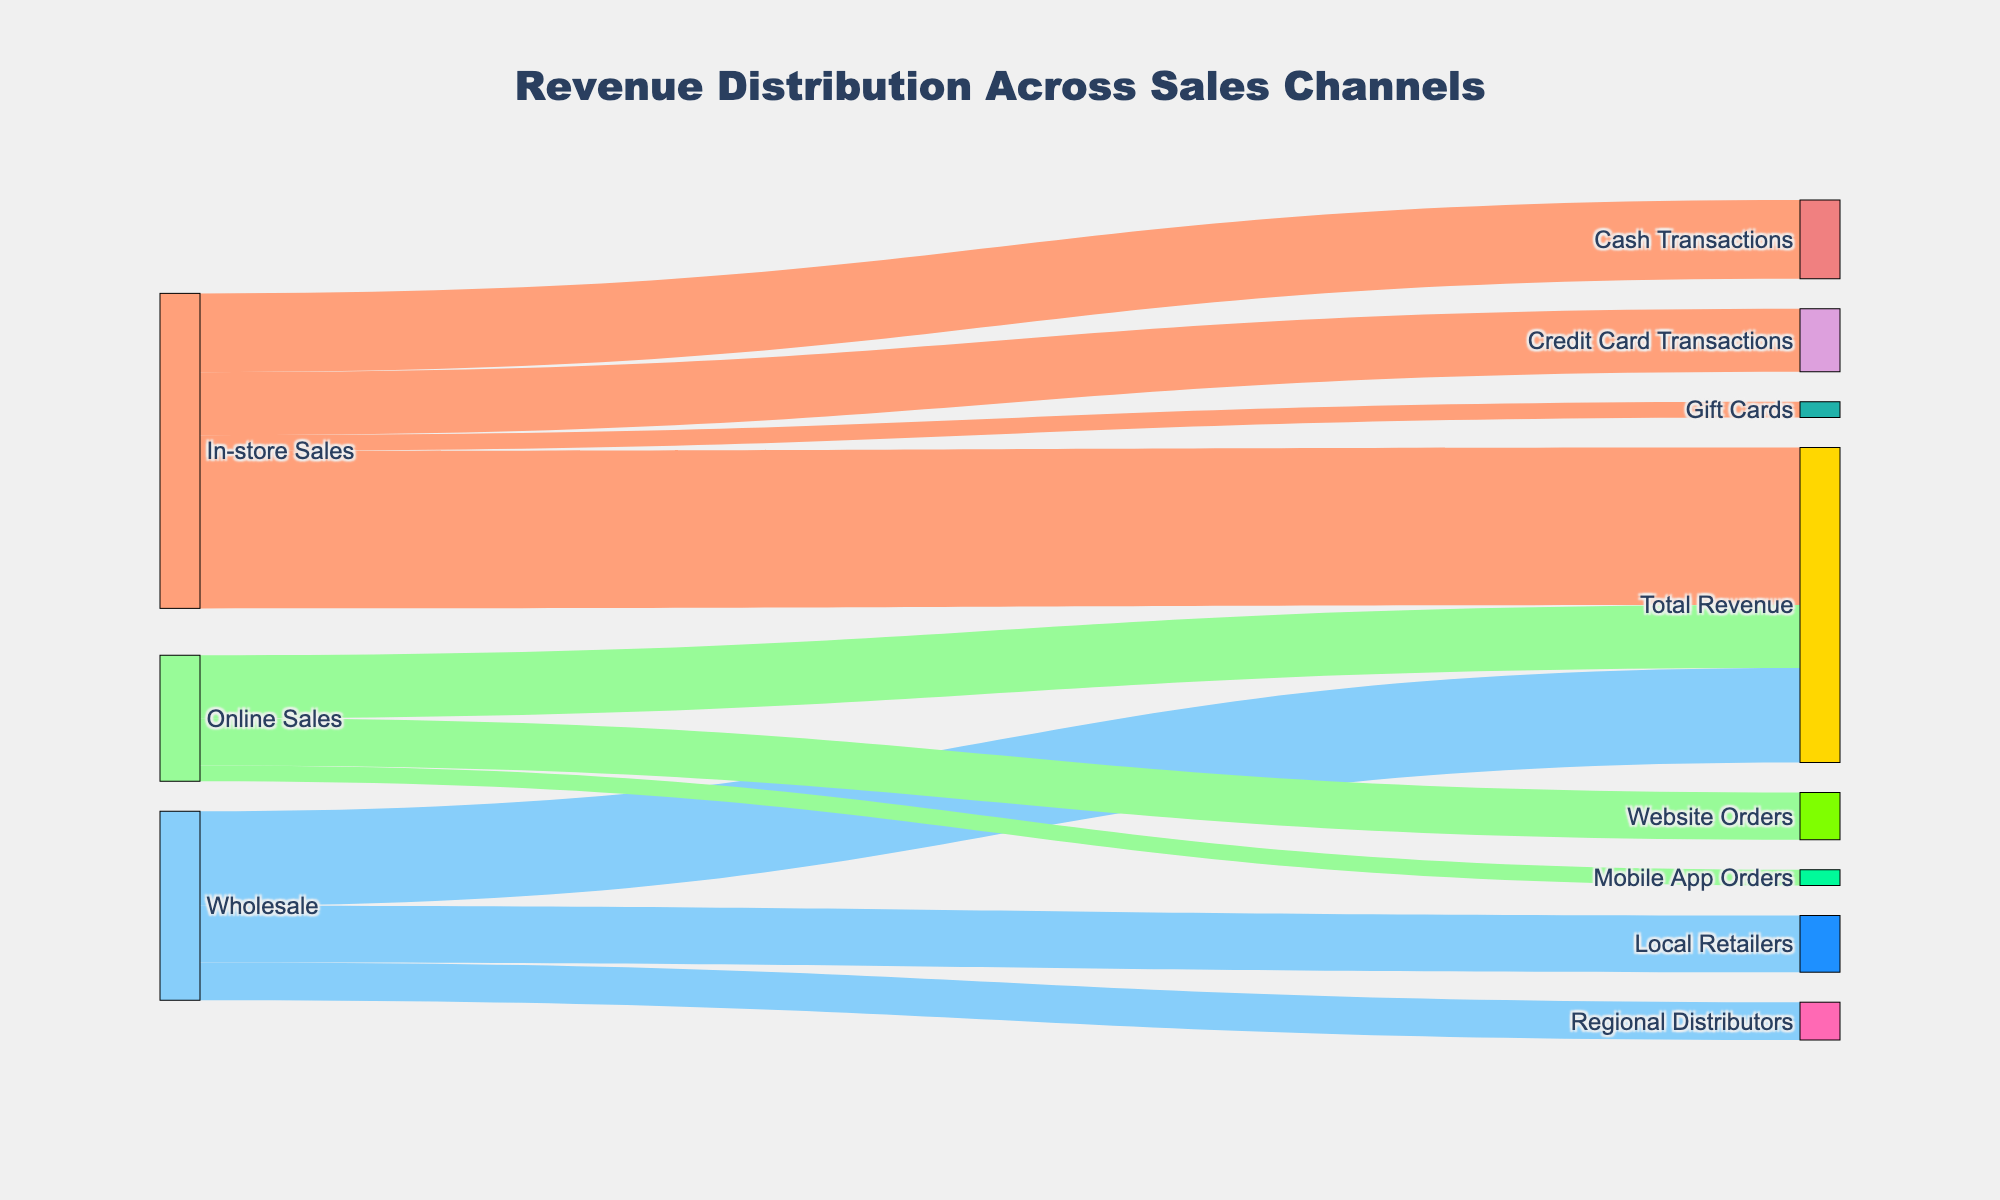What are the different sales channels shown in the diagram? The sales channels are the sources of revenue represented in the plot. These are visibly connected to the "Total Revenue".
Answer: In-store Sales, Online Sales, Wholesale Which sales channel contributes the most to the total revenue? Compare the values linked to the "Total Revenue" node for all sales channels. The highest value link indicates the largest contribution.
Answer: In-store Sales What is the combined revenue from Online Sales and Wholesale channels? Sum the values connected to the "Total Revenue" node from Online Sales and Wholesale: 180,000 + 270,000 = 450,000.
Answer: 450,000 Which transaction type within In-store Sales has the smallest value? Check the values linked to the node "In-store Sales". Compare the values of "Cash Transactions", "Credit Card Transactions", and "Gift Cards".
Answer: Gift Cards How does the revenue from Local Retailers compare with that from Regional Distributors within Wholesale? Compare the values linked to the "Wholesale" node. Local Retailers have a value of 162,000, and Regional Distributors have a value of 108,000.
Answer: Local Retailers has higher revenue What is the total value of transactions through digital platforms (Website Orders and Mobile App Orders)? Sum the values of Website Orders and Mobile App Orders connected to the "Online Sales" node: 135,000 + 45,000 = 180,000.
Answer: 180,000 What percentage of In-store Sales is made through Credit Card Transactions? Calculate the percentage by dividing the value of Credit Card Transactions by the total In-store Sales and multiply by 100: (180,000 / 450,000) * 100 = 40%.
Answer: 40% What is the proportion of the total revenue from Wholesale sales? Divide the value of Wholesale sales by the Total Revenue and multiply by 100: (270,000 / 900,000) * 100 = 30%.
Answer: 30% What's the total sum of revenue derived from Gift Cards, Mobile App Orders, and Regional Distributors combined? Add the individual values for Gift Cards, Mobile App Orders, and Regional Distributors: 45,000 + 45,000 + 108,000 = 198,000.
Answer: 198,000 